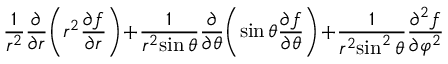<formula> <loc_0><loc_0><loc_500><loc_500>{ \frac { 1 } { r ^ { 2 } } } { \frac { \partial } { \partial r } } \, \left ( r ^ { 2 } { \frac { \partial f } { \partial r } } \right ) \, + \, { \frac { 1 } { r ^ { 2 } \, \sin \theta } } { \frac { \partial } { \partial \theta } } \, \left ( \sin \theta { \frac { \partial f } { \partial \theta } } \right ) \, + \, { \frac { 1 } { r ^ { 2 } \, \sin ^ { 2 } \theta } } { \frac { \partial ^ { 2 } f } { \partial \varphi ^ { 2 } } }</formula> 